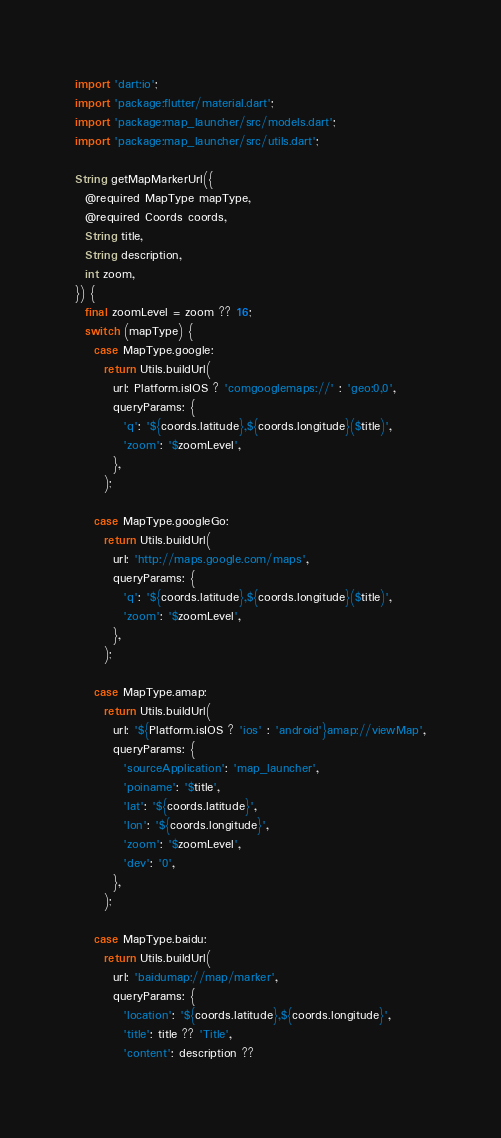Convert code to text. <code><loc_0><loc_0><loc_500><loc_500><_Dart_>import 'dart:io';
import 'package:flutter/material.dart';
import 'package:map_launcher/src/models.dart';
import 'package:map_launcher/src/utils.dart';

String getMapMarkerUrl({
  @required MapType mapType,
  @required Coords coords,
  String title,
  String description,
  int zoom,
}) {
  final zoomLevel = zoom ?? 16;
  switch (mapType) {
    case MapType.google:
      return Utils.buildUrl(
        url: Platform.isIOS ? 'comgooglemaps://' : 'geo:0,0',
        queryParams: {
          'q': '${coords.latitude},${coords.longitude}($title)',
          'zoom': '$zoomLevel',
        },
      );

    case MapType.googleGo:
      return Utils.buildUrl(
        url: 'http://maps.google.com/maps',
        queryParams: {
          'q': '${coords.latitude},${coords.longitude}($title)',
          'zoom': '$zoomLevel',
        },
      );

    case MapType.amap:
      return Utils.buildUrl(
        url: '${Platform.isIOS ? 'ios' : 'android'}amap://viewMap',
        queryParams: {
          'sourceApplication': 'map_launcher',
          'poiname': '$title',
          'lat': '${coords.latitude}',
          'lon': '${coords.longitude}',
          'zoom': '$zoomLevel',
          'dev': '0',
        },
      );

    case MapType.baidu:
      return Utils.buildUrl(
        url: 'baidumap://map/marker',
        queryParams: {
          'location': '${coords.latitude},${coords.longitude}',
          'title': title ?? 'Title',
          'content': description ??</code> 